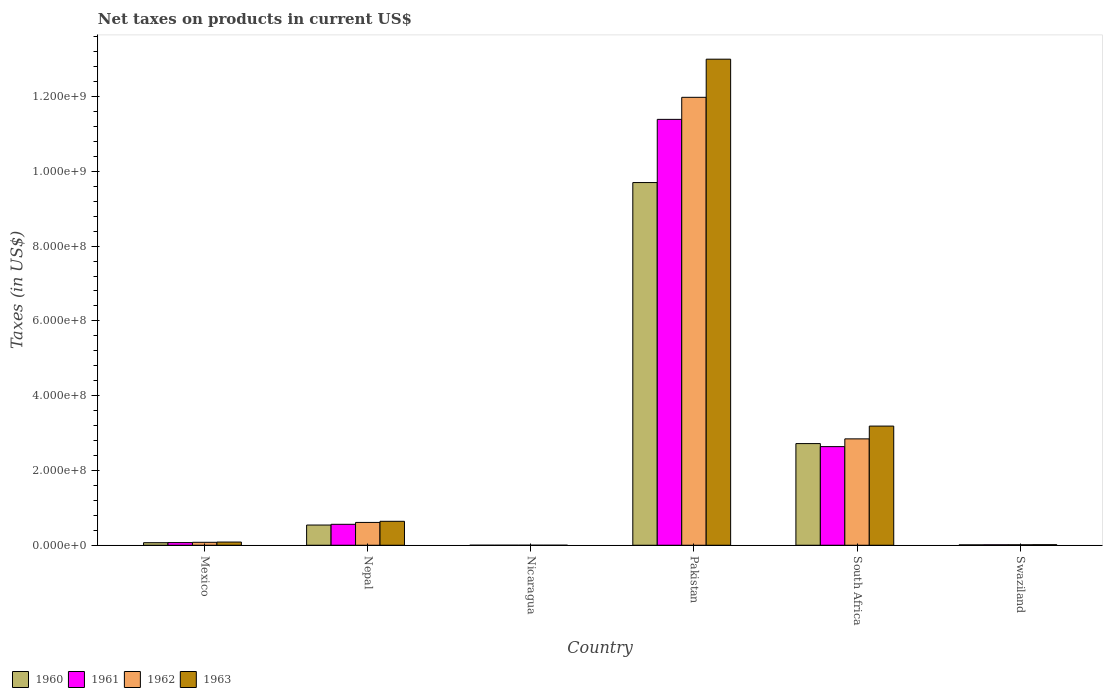How many different coloured bars are there?
Your response must be concise. 4. How many groups of bars are there?
Keep it short and to the point. 6. Are the number of bars per tick equal to the number of legend labels?
Keep it short and to the point. Yes. Are the number of bars on each tick of the X-axis equal?
Your answer should be very brief. Yes. How many bars are there on the 5th tick from the right?
Provide a succinct answer. 4. What is the label of the 2nd group of bars from the left?
Give a very brief answer. Nepal. In how many cases, is the number of bars for a given country not equal to the number of legend labels?
Offer a very short reply. 0. What is the net taxes on products in 1961 in Pakistan?
Your response must be concise. 1.14e+09. Across all countries, what is the maximum net taxes on products in 1960?
Make the answer very short. 9.70e+08. Across all countries, what is the minimum net taxes on products in 1960?
Ensure brevity in your answer.  0.03. In which country was the net taxes on products in 1961 maximum?
Your answer should be compact. Pakistan. In which country was the net taxes on products in 1963 minimum?
Provide a short and direct response. Nicaragua. What is the total net taxes on products in 1960 in the graph?
Offer a terse response. 1.30e+09. What is the difference between the net taxes on products in 1963 in Nicaragua and that in Pakistan?
Ensure brevity in your answer.  -1.30e+09. What is the difference between the net taxes on products in 1961 in South Africa and the net taxes on products in 1963 in Pakistan?
Your answer should be very brief. -1.04e+09. What is the average net taxes on products in 1960 per country?
Your answer should be very brief. 2.17e+08. What is the difference between the net taxes on products of/in 1960 and net taxes on products of/in 1962 in Nepal?
Provide a succinct answer. -7.00e+06. What is the ratio of the net taxes on products in 1961 in Nicaragua to that in South Africa?
Provide a succinct answer. 1.1808845174845643e-10. Is the net taxes on products in 1963 in Mexico less than that in Nepal?
Provide a short and direct response. Yes. What is the difference between the highest and the second highest net taxes on products in 1963?
Your answer should be compact. 2.55e+08. What is the difference between the highest and the lowest net taxes on products in 1961?
Ensure brevity in your answer.  1.14e+09. Is the sum of the net taxes on products in 1960 in Mexico and Nepal greater than the maximum net taxes on products in 1963 across all countries?
Provide a short and direct response. No. What does the 2nd bar from the left in South Africa represents?
Your answer should be very brief. 1961. What does the 3rd bar from the right in Pakistan represents?
Ensure brevity in your answer.  1961. Is it the case that in every country, the sum of the net taxes on products in 1963 and net taxes on products in 1961 is greater than the net taxes on products in 1962?
Your answer should be compact. Yes. Are all the bars in the graph horizontal?
Give a very brief answer. No. How many countries are there in the graph?
Your response must be concise. 6. Does the graph contain any zero values?
Your answer should be compact. No. Does the graph contain grids?
Give a very brief answer. No. Where does the legend appear in the graph?
Provide a succinct answer. Bottom left. How many legend labels are there?
Provide a succinct answer. 4. What is the title of the graph?
Keep it short and to the point. Net taxes on products in current US$. Does "1973" appear as one of the legend labels in the graph?
Offer a terse response. No. What is the label or title of the X-axis?
Provide a short and direct response. Country. What is the label or title of the Y-axis?
Your answer should be very brief. Taxes (in US$). What is the Taxes (in US$) in 1960 in Mexico?
Make the answer very short. 6.81e+06. What is the Taxes (in US$) in 1961 in Mexico?
Ensure brevity in your answer.  7.08e+06. What is the Taxes (in US$) in 1962 in Mexico?
Give a very brief answer. 7.85e+06. What is the Taxes (in US$) of 1963 in Mexico?
Your answer should be very brief. 8.49e+06. What is the Taxes (in US$) of 1960 in Nepal?
Provide a succinct answer. 5.40e+07. What is the Taxes (in US$) in 1961 in Nepal?
Your response must be concise. 5.60e+07. What is the Taxes (in US$) of 1962 in Nepal?
Provide a short and direct response. 6.10e+07. What is the Taxes (in US$) in 1963 in Nepal?
Provide a succinct answer. 6.40e+07. What is the Taxes (in US$) of 1960 in Nicaragua?
Your response must be concise. 0.03. What is the Taxes (in US$) of 1961 in Nicaragua?
Your response must be concise. 0.03. What is the Taxes (in US$) in 1962 in Nicaragua?
Keep it short and to the point. 0.04. What is the Taxes (in US$) in 1963 in Nicaragua?
Your answer should be compact. 0.04. What is the Taxes (in US$) of 1960 in Pakistan?
Keep it short and to the point. 9.70e+08. What is the Taxes (in US$) in 1961 in Pakistan?
Make the answer very short. 1.14e+09. What is the Taxes (in US$) of 1962 in Pakistan?
Make the answer very short. 1.20e+09. What is the Taxes (in US$) of 1963 in Pakistan?
Offer a very short reply. 1.30e+09. What is the Taxes (in US$) of 1960 in South Africa?
Give a very brief answer. 2.72e+08. What is the Taxes (in US$) in 1961 in South Africa?
Provide a succinct answer. 2.64e+08. What is the Taxes (in US$) of 1962 in South Africa?
Your answer should be very brief. 2.84e+08. What is the Taxes (in US$) in 1963 in South Africa?
Provide a succinct answer. 3.19e+08. What is the Taxes (in US$) of 1960 in Swaziland?
Give a very brief answer. 1.00e+06. What is the Taxes (in US$) in 1961 in Swaziland?
Offer a terse response. 1.21e+06. What is the Taxes (in US$) of 1962 in Swaziland?
Provide a short and direct response. 1.24e+06. What is the Taxes (in US$) in 1963 in Swaziland?
Ensure brevity in your answer.  1.47e+06. Across all countries, what is the maximum Taxes (in US$) of 1960?
Offer a terse response. 9.70e+08. Across all countries, what is the maximum Taxes (in US$) in 1961?
Give a very brief answer. 1.14e+09. Across all countries, what is the maximum Taxes (in US$) in 1962?
Provide a succinct answer. 1.20e+09. Across all countries, what is the maximum Taxes (in US$) of 1963?
Give a very brief answer. 1.30e+09. Across all countries, what is the minimum Taxes (in US$) of 1960?
Provide a short and direct response. 0.03. Across all countries, what is the minimum Taxes (in US$) in 1961?
Give a very brief answer. 0.03. Across all countries, what is the minimum Taxes (in US$) of 1962?
Offer a terse response. 0.04. Across all countries, what is the minimum Taxes (in US$) of 1963?
Offer a terse response. 0.04. What is the total Taxes (in US$) in 1960 in the graph?
Make the answer very short. 1.30e+09. What is the total Taxes (in US$) of 1961 in the graph?
Ensure brevity in your answer.  1.47e+09. What is the total Taxes (in US$) of 1962 in the graph?
Give a very brief answer. 1.55e+09. What is the total Taxes (in US$) in 1963 in the graph?
Your response must be concise. 1.69e+09. What is the difference between the Taxes (in US$) of 1960 in Mexico and that in Nepal?
Your answer should be very brief. -4.72e+07. What is the difference between the Taxes (in US$) in 1961 in Mexico and that in Nepal?
Your answer should be very brief. -4.89e+07. What is the difference between the Taxes (in US$) in 1962 in Mexico and that in Nepal?
Ensure brevity in your answer.  -5.32e+07. What is the difference between the Taxes (in US$) of 1963 in Mexico and that in Nepal?
Provide a succinct answer. -5.55e+07. What is the difference between the Taxes (in US$) in 1960 in Mexico and that in Nicaragua?
Your response must be concise. 6.81e+06. What is the difference between the Taxes (in US$) in 1961 in Mexico and that in Nicaragua?
Keep it short and to the point. 7.08e+06. What is the difference between the Taxes (in US$) of 1962 in Mexico and that in Nicaragua?
Your answer should be very brief. 7.85e+06. What is the difference between the Taxes (in US$) of 1963 in Mexico and that in Nicaragua?
Your answer should be compact. 8.49e+06. What is the difference between the Taxes (in US$) of 1960 in Mexico and that in Pakistan?
Make the answer very short. -9.63e+08. What is the difference between the Taxes (in US$) of 1961 in Mexico and that in Pakistan?
Your response must be concise. -1.13e+09. What is the difference between the Taxes (in US$) in 1962 in Mexico and that in Pakistan?
Offer a very short reply. -1.19e+09. What is the difference between the Taxes (in US$) of 1963 in Mexico and that in Pakistan?
Ensure brevity in your answer.  -1.29e+09. What is the difference between the Taxes (in US$) in 1960 in Mexico and that in South Africa?
Your answer should be very brief. -2.65e+08. What is the difference between the Taxes (in US$) of 1961 in Mexico and that in South Africa?
Your answer should be compact. -2.57e+08. What is the difference between the Taxes (in US$) in 1962 in Mexico and that in South Africa?
Offer a terse response. -2.77e+08. What is the difference between the Taxes (in US$) of 1963 in Mexico and that in South Africa?
Provide a short and direct response. -3.10e+08. What is the difference between the Taxes (in US$) of 1960 in Mexico and that in Swaziland?
Keep it short and to the point. 5.80e+06. What is the difference between the Taxes (in US$) of 1961 in Mexico and that in Swaziland?
Your answer should be very brief. 5.87e+06. What is the difference between the Taxes (in US$) in 1962 in Mexico and that in Swaziland?
Make the answer very short. 6.61e+06. What is the difference between the Taxes (in US$) in 1963 in Mexico and that in Swaziland?
Your answer should be compact. 7.02e+06. What is the difference between the Taxes (in US$) in 1960 in Nepal and that in Nicaragua?
Your answer should be compact. 5.40e+07. What is the difference between the Taxes (in US$) of 1961 in Nepal and that in Nicaragua?
Ensure brevity in your answer.  5.60e+07. What is the difference between the Taxes (in US$) of 1962 in Nepal and that in Nicaragua?
Your answer should be compact. 6.10e+07. What is the difference between the Taxes (in US$) of 1963 in Nepal and that in Nicaragua?
Give a very brief answer. 6.40e+07. What is the difference between the Taxes (in US$) in 1960 in Nepal and that in Pakistan?
Your response must be concise. -9.16e+08. What is the difference between the Taxes (in US$) of 1961 in Nepal and that in Pakistan?
Offer a terse response. -1.08e+09. What is the difference between the Taxes (in US$) of 1962 in Nepal and that in Pakistan?
Give a very brief answer. -1.14e+09. What is the difference between the Taxes (in US$) in 1963 in Nepal and that in Pakistan?
Keep it short and to the point. -1.24e+09. What is the difference between the Taxes (in US$) in 1960 in Nepal and that in South Africa?
Offer a terse response. -2.18e+08. What is the difference between the Taxes (in US$) of 1961 in Nepal and that in South Africa?
Give a very brief answer. -2.08e+08. What is the difference between the Taxes (in US$) in 1962 in Nepal and that in South Africa?
Your answer should be very brief. -2.23e+08. What is the difference between the Taxes (in US$) of 1963 in Nepal and that in South Africa?
Provide a short and direct response. -2.55e+08. What is the difference between the Taxes (in US$) of 1960 in Nepal and that in Swaziland?
Offer a very short reply. 5.30e+07. What is the difference between the Taxes (in US$) of 1961 in Nepal and that in Swaziland?
Offer a very short reply. 5.48e+07. What is the difference between the Taxes (in US$) of 1962 in Nepal and that in Swaziland?
Your answer should be compact. 5.98e+07. What is the difference between the Taxes (in US$) in 1963 in Nepal and that in Swaziland?
Make the answer very short. 6.25e+07. What is the difference between the Taxes (in US$) of 1960 in Nicaragua and that in Pakistan?
Offer a very short reply. -9.70e+08. What is the difference between the Taxes (in US$) of 1961 in Nicaragua and that in Pakistan?
Ensure brevity in your answer.  -1.14e+09. What is the difference between the Taxes (in US$) in 1962 in Nicaragua and that in Pakistan?
Provide a succinct answer. -1.20e+09. What is the difference between the Taxes (in US$) of 1963 in Nicaragua and that in Pakistan?
Offer a terse response. -1.30e+09. What is the difference between the Taxes (in US$) of 1960 in Nicaragua and that in South Africa?
Offer a very short reply. -2.72e+08. What is the difference between the Taxes (in US$) of 1961 in Nicaragua and that in South Africa?
Your answer should be very brief. -2.64e+08. What is the difference between the Taxes (in US$) of 1962 in Nicaragua and that in South Africa?
Make the answer very short. -2.84e+08. What is the difference between the Taxes (in US$) of 1963 in Nicaragua and that in South Africa?
Your response must be concise. -3.19e+08. What is the difference between the Taxes (in US$) in 1960 in Nicaragua and that in Swaziland?
Keep it short and to the point. -1.00e+06. What is the difference between the Taxes (in US$) of 1961 in Nicaragua and that in Swaziland?
Make the answer very short. -1.21e+06. What is the difference between the Taxes (in US$) of 1962 in Nicaragua and that in Swaziland?
Make the answer very short. -1.24e+06. What is the difference between the Taxes (in US$) of 1963 in Nicaragua and that in Swaziland?
Offer a terse response. -1.47e+06. What is the difference between the Taxes (in US$) in 1960 in Pakistan and that in South Africa?
Make the answer very short. 6.98e+08. What is the difference between the Taxes (in US$) of 1961 in Pakistan and that in South Africa?
Ensure brevity in your answer.  8.75e+08. What is the difference between the Taxes (in US$) in 1962 in Pakistan and that in South Africa?
Offer a very short reply. 9.14e+08. What is the difference between the Taxes (in US$) in 1963 in Pakistan and that in South Africa?
Make the answer very short. 9.81e+08. What is the difference between the Taxes (in US$) of 1960 in Pakistan and that in Swaziland?
Make the answer very short. 9.69e+08. What is the difference between the Taxes (in US$) in 1961 in Pakistan and that in Swaziland?
Keep it short and to the point. 1.14e+09. What is the difference between the Taxes (in US$) in 1962 in Pakistan and that in Swaziland?
Give a very brief answer. 1.20e+09. What is the difference between the Taxes (in US$) of 1963 in Pakistan and that in Swaziland?
Your response must be concise. 1.30e+09. What is the difference between the Taxes (in US$) in 1960 in South Africa and that in Swaziland?
Make the answer very short. 2.71e+08. What is the difference between the Taxes (in US$) of 1961 in South Africa and that in Swaziland?
Keep it short and to the point. 2.63e+08. What is the difference between the Taxes (in US$) of 1962 in South Africa and that in Swaziland?
Give a very brief answer. 2.83e+08. What is the difference between the Taxes (in US$) of 1963 in South Africa and that in Swaziland?
Offer a terse response. 3.17e+08. What is the difference between the Taxes (in US$) in 1960 in Mexico and the Taxes (in US$) in 1961 in Nepal?
Keep it short and to the point. -4.92e+07. What is the difference between the Taxes (in US$) of 1960 in Mexico and the Taxes (in US$) of 1962 in Nepal?
Provide a succinct answer. -5.42e+07. What is the difference between the Taxes (in US$) in 1960 in Mexico and the Taxes (in US$) in 1963 in Nepal?
Offer a terse response. -5.72e+07. What is the difference between the Taxes (in US$) in 1961 in Mexico and the Taxes (in US$) in 1962 in Nepal?
Provide a succinct answer. -5.39e+07. What is the difference between the Taxes (in US$) in 1961 in Mexico and the Taxes (in US$) in 1963 in Nepal?
Offer a very short reply. -5.69e+07. What is the difference between the Taxes (in US$) in 1962 in Mexico and the Taxes (in US$) in 1963 in Nepal?
Your answer should be compact. -5.62e+07. What is the difference between the Taxes (in US$) in 1960 in Mexico and the Taxes (in US$) in 1961 in Nicaragua?
Keep it short and to the point. 6.81e+06. What is the difference between the Taxes (in US$) in 1960 in Mexico and the Taxes (in US$) in 1962 in Nicaragua?
Give a very brief answer. 6.81e+06. What is the difference between the Taxes (in US$) in 1960 in Mexico and the Taxes (in US$) in 1963 in Nicaragua?
Provide a short and direct response. 6.81e+06. What is the difference between the Taxes (in US$) in 1961 in Mexico and the Taxes (in US$) in 1962 in Nicaragua?
Your answer should be very brief. 7.08e+06. What is the difference between the Taxes (in US$) in 1961 in Mexico and the Taxes (in US$) in 1963 in Nicaragua?
Ensure brevity in your answer.  7.08e+06. What is the difference between the Taxes (in US$) of 1962 in Mexico and the Taxes (in US$) of 1963 in Nicaragua?
Provide a short and direct response. 7.85e+06. What is the difference between the Taxes (in US$) of 1960 in Mexico and the Taxes (in US$) of 1961 in Pakistan?
Your response must be concise. -1.13e+09. What is the difference between the Taxes (in US$) in 1960 in Mexico and the Taxes (in US$) in 1962 in Pakistan?
Give a very brief answer. -1.19e+09. What is the difference between the Taxes (in US$) in 1960 in Mexico and the Taxes (in US$) in 1963 in Pakistan?
Give a very brief answer. -1.29e+09. What is the difference between the Taxes (in US$) of 1961 in Mexico and the Taxes (in US$) of 1962 in Pakistan?
Make the answer very short. -1.19e+09. What is the difference between the Taxes (in US$) in 1961 in Mexico and the Taxes (in US$) in 1963 in Pakistan?
Your answer should be very brief. -1.29e+09. What is the difference between the Taxes (in US$) of 1962 in Mexico and the Taxes (in US$) of 1963 in Pakistan?
Offer a very short reply. -1.29e+09. What is the difference between the Taxes (in US$) of 1960 in Mexico and the Taxes (in US$) of 1961 in South Africa?
Make the answer very short. -2.57e+08. What is the difference between the Taxes (in US$) in 1960 in Mexico and the Taxes (in US$) in 1962 in South Africa?
Offer a terse response. -2.78e+08. What is the difference between the Taxes (in US$) of 1960 in Mexico and the Taxes (in US$) of 1963 in South Africa?
Your answer should be compact. -3.12e+08. What is the difference between the Taxes (in US$) in 1961 in Mexico and the Taxes (in US$) in 1962 in South Africa?
Your answer should be compact. -2.77e+08. What is the difference between the Taxes (in US$) in 1961 in Mexico and the Taxes (in US$) in 1963 in South Africa?
Your answer should be compact. -3.12e+08. What is the difference between the Taxes (in US$) in 1962 in Mexico and the Taxes (in US$) in 1963 in South Africa?
Your answer should be very brief. -3.11e+08. What is the difference between the Taxes (in US$) in 1960 in Mexico and the Taxes (in US$) in 1961 in Swaziland?
Your answer should be compact. 5.60e+06. What is the difference between the Taxes (in US$) in 1960 in Mexico and the Taxes (in US$) in 1962 in Swaziland?
Offer a terse response. 5.57e+06. What is the difference between the Taxes (in US$) of 1960 in Mexico and the Taxes (in US$) of 1963 in Swaziland?
Provide a succinct answer. 5.33e+06. What is the difference between the Taxes (in US$) in 1961 in Mexico and the Taxes (in US$) in 1962 in Swaziland?
Your answer should be very brief. 5.84e+06. What is the difference between the Taxes (in US$) of 1961 in Mexico and the Taxes (in US$) of 1963 in Swaziland?
Make the answer very short. 5.61e+06. What is the difference between the Taxes (in US$) of 1962 in Mexico and the Taxes (in US$) of 1963 in Swaziland?
Your answer should be compact. 6.37e+06. What is the difference between the Taxes (in US$) of 1960 in Nepal and the Taxes (in US$) of 1961 in Nicaragua?
Your answer should be compact. 5.40e+07. What is the difference between the Taxes (in US$) in 1960 in Nepal and the Taxes (in US$) in 1962 in Nicaragua?
Your answer should be very brief. 5.40e+07. What is the difference between the Taxes (in US$) of 1960 in Nepal and the Taxes (in US$) of 1963 in Nicaragua?
Make the answer very short. 5.40e+07. What is the difference between the Taxes (in US$) of 1961 in Nepal and the Taxes (in US$) of 1962 in Nicaragua?
Your answer should be compact. 5.60e+07. What is the difference between the Taxes (in US$) of 1961 in Nepal and the Taxes (in US$) of 1963 in Nicaragua?
Make the answer very short. 5.60e+07. What is the difference between the Taxes (in US$) of 1962 in Nepal and the Taxes (in US$) of 1963 in Nicaragua?
Offer a very short reply. 6.10e+07. What is the difference between the Taxes (in US$) of 1960 in Nepal and the Taxes (in US$) of 1961 in Pakistan?
Your answer should be compact. -1.08e+09. What is the difference between the Taxes (in US$) in 1960 in Nepal and the Taxes (in US$) in 1962 in Pakistan?
Your answer should be very brief. -1.14e+09. What is the difference between the Taxes (in US$) in 1960 in Nepal and the Taxes (in US$) in 1963 in Pakistan?
Make the answer very short. -1.25e+09. What is the difference between the Taxes (in US$) in 1961 in Nepal and the Taxes (in US$) in 1962 in Pakistan?
Offer a very short reply. -1.14e+09. What is the difference between the Taxes (in US$) in 1961 in Nepal and the Taxes (in US$) in 1963 in Pakistan?
Give a very brief answer. -1.24e+09. What is the difference between the Taxes (in US$) of 1962 in Nepal and the Taxes (in US$) of 1963 in Pakistan?
Give a very brief answer. -1.24e+09. What is the difference between the Taxes (in US$) in 1960 in Nepal and the Taxes (in US$) in 1961 in South Africa?
Provide a succinct answer. -2.10e+08. What is the difference between the Taxes (in US$) in 1960 in Nepal and the Taxes (in US$) in 1962 in South Africa?
Ensure brevity in your answer.  -2.30e+08. What is the difference between the Taxes (in US$) of 1960 in Nepal and the Taxes (in US$) of 1963 in South Africa?
Your answer should be compact. -2.65e+08. What is the difference between the Taxes (in US$) of 1961 in Nepal and the Taxes (in US$) of 1962 in South Africa?
Provide a succinct answer. -2.28e+08. What is the difference between the Taxes (in US$) in 1961 in Nepal and the Taxes (in US$) in 1963 in South Africa?
Provide a succinct answer. -2.63e+08. What is the difference between the Taxes (in US$) in 1962 in Nepal and the Taxes (in US$) in 1963 in South Africa?
Your response must be concise. -2.58e+08. What is the difference between the Taxes (in US$) in 1960 in Nepal and the Taxes (in US$) in 1961 in Swaziland?
Ensure brevity in your answer.  5.28e+07. What is the difference between the Taxes (in US$) in 1960 in Nepal and the Taxes (in US$) in 1962 in Swaziland?
Give a very brief answer. 5.28e+07. What is the difference between the Taxes (in US$) of 1960 in Nepal and the Taxes (in US$) of 1963 in Swaziland?
Your answer should be compact. 5.25e+07. What is the difference between the Taxes (in US$) of 1961 in Nepal and the Taxes (in US$) of 1962 in Swaziland?
Make the answer very short. 5.48e+07. What is the difference between the Taxes (in US$) of 1961 in Nepal and the Taxes (in US$) of 1963 in Swaziland?
Offer a very short reply. 5.45e+07. What is the difference between the Taxes (in US$) of 1962 in Nepal and the Taxes (in US$) of 1963 in Swaziland?
Provide a short and direct response. 5.95e+07. What is the difference between the Taxes (in US$) of 1960 in Nicaragua and the Taxes (in US$) of 1961 in Pakistan?
Provide a succinct answer. -1.14e+09. What is the difference between the Taxes (in US$) of 1960 in Nicaragua and the Taxes (in US$) of 1962 in Pakistan?
Your answer should be very brief. -1.20e+09. What is the difference between the Taxes (in US$) in 1960 in Nicaragua and the Taxes (in US$) in 1963 in Pakistan?
Offer a terse response. -1.30e+09. What is the difference between the Taxes (in US$) of 1961 in Nicaragua and the Taxes (in US$) of 1962 in Pakistan?
Your response must be concise. -1.20e+09. What is the difference between the Taxes (in US$) of 1961 in Nicaragua and the Taxes (in US$) of 1963 in Pakistan?
Provide a succinct answer. -1.30e+09. What is the difference between the Taxes (in US$) in 1962 in Nicaragua and the Taxes (in US$) in 1963 in Pakistan?
Your response must be concise. -1.30e+09. What is the difference between the Taxes (in US$) in 1960 in Nicaragua and the Taxes (in US$) in 1961 in South Africa?
Offer a very short reply. -2.64e+08. What is the difference between the Taxes (in US$) in 1960 in Nicaragua and the Taxes (in US$) in 1962 in South Africa?
Give a very brief answer. -2.84e+08. What is the difference between the Taxes (in US$) of 1960 in Nicaragua and the Taxes (in US$) of 1963 in South Africa?
Your answer should be very brief. -3.19e+08. What is the difference between the Taxes (in US$) in 1961 in Nicaragua and the Taxes (in US$) in 1962 in South Africa?
Ensure brevity in your answer.  -2.84e+08. What is the difference between the Taxes (in US$) in 1961 in Nicaragua and the Taxes (in US$) in 1963 in South Africa?
Keep it short and to the point. -3.19e+08. What is the difference between the Taxes (in US$) in 1962 in Nicaragua and the Taxes (in US$) in 1963 in South Africa?
Ensure brevity in your answer.  -3.19e+08. What is the difference between the Taxes (in US$) in 1960 in Nicaragua and the Taxes (in US$) in 1961 in Swaziland?
Give a very brief answer. -1.21e+06. What is the difference between the Taxes (in US$) of 1960 in Nicaragua and the Taxes (in US$) of 1962 in Swaziland?
Offer a terse response. -1.24e+06. What is the difference between the Taxes (in US$) in 1960 in Nicaragua and the Taxes (in US$) in 1963 in Swaziland?
Offer a very short reply. -1.47e+06. What is the difference between the Taxes (in US$) of 1961 in Nicaragua and the Taxes (in US$) of 1962 in Swaziland?
Make the answer very short. -1.24e+06. What is the difference between the Taxes (in US$) of 1961 in Nicaragua and the Taxes (in US$) of 1963 in Swaziland?
Keep it short and to the point. -1.47e+06. What is the difference between the Taxes (in US$) of 1962 in Nicaragua and the Taxes (in US$) of 1963 in Swaziland?
Your answer should be compact. -1.47e+06. What is the difference between the Taxes (in US$) in 1960 in Pakistan and the Taxes (in US$) in 1961 in South Africa?
Ensure brevity in your answer.  7.06e+08. What is the difference between the Taxes (in US$) of 1960 in Pakistan and the Taxes (in US$) of 1962 in South Africa?
Provide a short and direct response. 6.86e+08. What is the difference between the Taxes (in US$) in 1960 in Pakistan and the Taxes (in US$) in 1963 in South Africa?
Give a very brief answer. 6.51e+08. What is the difference between the Taxes (in US$) in 1961 in Pakistan and the Taxes (in US$) in 1962 in South Africa?
Provide a succinct answer. 8.55e+08. What is the difference between the Taxes (in US$) in 1961 in Pakistan and the Taxes (in US$) in 1963 in South Africa?
Make the answer very short. 8.20e+08. What is the difference between the Taxes (in US$) in 1962 in Pakistan and the Taxes (in US$) in 1963 in South Africa?
Offer a terse response. 8.79e+08. What is the difference between the Taxes (in US$) of 1960 in Pakistan and the Taxes (in US$) of 1961 in Swaziland?
Offer a terse response. 9.69e+08. What is the difference between the Taxes (in US$) of 1960 in Pakistan and the Taxes (in US$) of 1962 in Swaziland?
Your answer should be very brief. 9.69e+08. What is the difference between the Taxes (in US$) of 1960 in Pakistan and the Taxes (in US$) of 1963 in Swaziland?
Your response must be concise. 9.69e+08. What is the difference between the Taxes (in US$) in 1961 in Pakistan and the Taxes (in US$) in 1962 in Swaziland?
Ensure brevity in your answer.  1.14e+09. What is the difference between the Taxes (in US$) of 1961 in Pakistan and the Taxes (in US$) of 1963 in Swaziland?
Your response must be concise. 1.14e+09. What is the difference between the Taxes (in US$) of 1962 in Pakistan and the Taxes (in US$) of 1963 in Swaziland?
Your answer should be very brief. 1.20e+09. What is the difference between the Taxes (in US$) in 1960 in South Africa and the Taxes (in US$) in 1961 in Swaziland?
Give a very brief answer. 2.71e+08. What is the difference between the Taxes (in US$) of 1960 in South Africa and the Taxes (in US$) of 1962 in Swaziland?
Provide a short and direct response. 2.71e+08. What is the difference between the Taxes (in US$) in 1960 in South Africa and the Taxes (in US$) in 1963 in Swaziland?
Give a very brief answer. 2.70e+08. What is the difference between the Taxes (in US$) of 1961 in South Africa and the Taxes (in US$) of 1962 in Swaziland?
Offer a very short reply. 2.63e+08. What is the difference between the Taxes (in US$) of 1961 in South Africa and the Taxes (in US$) of 1963 in Swaziland?
Your answer should be compact. 2.62e+08. What is the difference between the Taxes (in US$) of 1962 in South Africa and the Taxes (in US$) of 1963 in Swaziland?
Offer a terse response. 2.83e+08. What is the average Taxes (in US$) in 1960 per country?
Keep it short and to the point. 2.17e+08. What is the average Taxes (in US$) of 1961 per country?
Offer a very short reply. 2.45e+08. What is the average Taxes (in US$) in 1962 per country?
Ensure brevity in your answer.  2.59e+08. What is the average Taxes (in US$) in 1963 per country?
Provide a succinct answer. 2.82e+08. What is the difference between the Taxes (in US$) in 1960 and Taxes (in US$) in 1961 in Mexico?
Your answer should be compact. -2.73e+05. What is the difference between the Taxes (in US$) of 1960 and Taxes (in US$) of 1962 in Mexico?
Provide a short and direct response. -1.04e+06. What is the difference between the Taxes (in US$) in 1960 and Taxes (in US$) in 1963 in Mexico?
Offer a very short reply. -1.69e+06. What is the difference between the Taxes (in US$) of 1961 and Taxes (in US$) of 1962 in Mexico?
Keep it short and to the point. -7.69e+05. What is the difference between the Taxes (in US$) of 1961 and Taxes (in US$) of 1963 in Mexico?
Offer a terse response. -1.41e+06. What is the difference between the Taxes (in US$) in 1962 and Taxes (in US$) in 1963 in Mexico?
Give a very brief answer. -6.43e+05. What is the difference between the Taxes (in US$) of 1960 and Taxes (in US$) of 1961 in Nepal?
Your response must be concise. -2.00e+06. What is the difference between the Taxes (in US$) of 1960 and Taxes (in US$) of 1962 in Nepal?
Keep it short and to the point. -7.00e+06. What is the difference between the Taxes (in US$) of 1960 and Taxes (in US$) of 1963 in Nepal?
Offer a terse response. -1.00e+07. What is the difference between the Taxes (in US$) of 1961 and Taxes (in US$) of 1962 in Nepal?
Make the answer very short. -5.00e+06. What is the difference between the Taxes (in US$) in 1961 and Taxes (in US$) in 1963 in Nepal?
Ensure brevity in your answer.  -8.00e+06. What is the difference between the Taxes (in US$) of 1962 and Taxes (in US$) of 1963 in Nepal?
Ensure brevity in your answer.  -3.00e+06. What is the difference between the Taxes (in US$) of 1960 and Taxes (in US$) of 1961 in Nicaragua?
Your answer should be compact. -0. What is the difference between the Taxes (in US$) of 1960 and Taxes (in US$) of 1962 in Nicaragua?
Make the answer very short. -0.01. What is the difference between the Taxes (in US$) of 1960 and Taxes (in US$) of 1963 in Nicaragua?
Give a very brief answer. -0.01. What is the difference between the Taxes (in US$) of 1961 and Taxes (in US$) of 1962 in Nicaragua?
Provide a succinct answer. -0. What is the difference between the Taxes (in US$) in 1961 and Taxes (in US$) in 1963 in Nicaragua?
Keep it short and to the point. -0.01. What is the difference between the Taxes (in US$) of 1962 and Taxes (in US$) of 1963 in Nicaragua?
Give a very brief answer. -0.01. What is the difference between the Taxes (in US$) in 1960 and Taxes (in US$) in 1961 in Pakistan?
Provide a succinct answer. -1.69e+08. What is the difference between the Taxes (in US$) in 1960 and Taxes (in US$) in 1962 in Pakistan?
Your response must be concise. -2.28e+08. What is the difference between the Taxes (in US$) in 1960 and Taxes (in US$) in 1963 in Pakistan?
Your answer should be very brief. -3.30e+08. What is the difference between the Taxes (in US$) of 1961 and Taxes (in US$) of 1962 in Pakistan?
Your answer should be compact. -5.90e+07. What is the difference between the Taxes (in US$) of 1961 and Taxes (in US$) of 1963 in Pakistan?
Make the answer very short. -1.61e+08. What is the difference between the Taxes (in US$) in 1962 and Taxes (in US$) in 1963 in Pakistan?
Your answer should be compact. -1.02e+08. What is the difference between the Taxes (in US$) of 1960 and Taxes (in US$) of 1961 in South Africa?
Ensure brevity in your answer.  8.10e+06. What is the difference between the Taxes (in US$) of 1960 and Taxes (in US$) of 1962 in South Africa?
Your response must be concise. -1.26e+07. What is the difference between the Taxes (in US$) of 1960 and Taxes (in US$) of 1963 in South Africa?
Provide a succinct answer. -4.68e+07. What is the difference between the Taxes (in US$) in 1961 and Taxes (in US$) in 1962 in South Africa?
Your response must be concise. -2.07e+07. What is the difference between the Taxes (in US$) in 1961 and Taxes (in US$) in 1963 in South Africa?
Offer a very short reply. -5.49e+07. What is the difference between the Taxes (in US$) in 1962 and Taxes (in US$) in 1963 in South Africa?
Make the answer very short. -3.42e+07. What is the difference between the Taxes (in US$) in 1960 and Taxes (in US$) in 1961 in Swaziland?
Offer a very short reply. -2.06e+05. What is the difference between the Taxes (in US$) in 1960 and Taxes (in US$) in 1962 in Swaziland?
Ensure brevity in your answer.  -2.36e+05. What is the difference between the Taxes (in US$) in 1960 and Taxes (in US$) in 1963 in Swaziland?
Provide a succinct answer. -4.72e+05. What is the difference between the Taxes (in US$) in 1961 and Taxes (in US$) in 1962 in Swaziland?
Make the answer very short. -2.95e+04. What is the difference between the Taxes (in US$) of 1961 and Taxes (in US$) of 1963 in Swaziland?
Make the answer very short. -2.65e+05. What is the difference between the Taxes (in US$) in 1962 and Taxes (in US$) in 1963 in Swaziland?
Your answer should be very brief. -2.36e+05. What is the ratio of the Taxes (in US$) of 1960 in Mexico to that in Nepal?
Provide a succinct answer. 0.13. What is the ratio of the Taxes (in US$) of 1961 in Mexico to that in Nepal?
Keep it short and to the point. 0.13. What is the ratio of the Taxes (in US$) in 1962 in Mexico to that in Nepal?
Make the answer very short. 0.13. What is the ratio of the Taxes (in US$) in 1963 in Mexico to that in Nepal?
Keep it short and to the point. 0.13. What is the ratio of the Taxes (in US$) in 1960 in Mexico to that in Nicaragua?
Make the answer very short. 2.29e+08. What is the ratio of the Taxes (in US$) of 1961 in Mexico to that in Nicaragua?
Offer a very short reply. 2.27e+08. What is the ratio of the Taxes (in US$) of 1962 in Mexico to that in Nicaragua?
Provide a succinct answer. 2.22e+08. What is the ratio of the Taxes (in US$) in 1963 in Mexico to that in Nicaragua?
Your answer should be compact. 2.04e+08. What is the ratio of the Taxes (in US$) in 1960 in Mexico to that in Pakistan?
Make the answer very short. 0.01. What is the ratio of the Taxes (in US$) of 1961 in Mexico to that in Pakistan?
Offer a very short reply. 0.01. What is the ratio of the Taxes (in US$) in 1962 in Mexico to that in Pakistan?
Provide a short and direct response. 0.01. What is the ratio of the Taxes (in US$) of 1963 in Mexico to that in Pakistan?
Provide a succinct answer. 0.01. What is the ratio of the Taxes (in US$) of 1960 in Mexico to that in South Africa?
Your response must be concise. 0.03. What is the ratio of the Taxes (in US$) of 1961 in Mexico to that in South Africa?
Provide a succinct answer. 0.03. What is the ratio of the Taxes (in US$) of 1962 in Mexico to that in South Africa?
Your answer should be compact. 0.03. What is the ratio of the Taxes (in US$) in 1963 in Mexico to that in South Africa?
Offer a very short reply. 0.03. What is the ratio of the Taxes (in US$) in 1960 in Mexico to that in Swaziland?
Ensure brevity in your answer.  6.79. What is the ratio of the Taxes (in US$) of 1961 in Mexico to that in Swaziland?
Your answer should be very brief. 5.86. What is the ratio of the Taxes (in US$) of 1962 in Mexico to that in Swaziland?
Provide a succinct answer. 6.34. What is the ratio of the Taxes (in US$) in 1963 in Mexico to that in Swaziland?
Keep it short and to the point. 5.76. What is the ratio of the Taxes (in US$) in 1960 in Nepal to that in Nicaragua?
Offer a terse response. 1.81e+09. What is the ratio of the Taxes (in US$) of 1961 in Nepal to that in Nicaragua?
Provide a short and direct response. 1.80e+09. What is the ratio of the Taxes (in US$) of 1962 in Nepal to that in Nicaragua?
Offer a terse response. 1.73e+09. What is the ratio of the Taxes (in US$) of 1963 in Nepal to that in Nicaragua?
Offer a terse response. 1.54e+09. What is the ratio of the Taxes (in US$) of 1960 in Nepal to that in Pakistan?
Offer a terse response. 0.06. What is the ratio of the Taxes (in US$) of 1961 in Nepal to that in Pakistan?
Keep it short and to the point. 0.05. What is the ratio of the Taxes (in US$) in 1962 in Nepal to that in Pakistan?
Ensure brevity in your answer.  0.05. What is the ratio of the Taxes (in US$) of 1963 in Nepal to that in Pakistan?
Offer a very short reply. 0.05. What is the ratio of the Taxes (in US$) in 1960 in Nepal to that in South Africa?
Your answer should be very brief. 0.2. What is the ratio of the Taxes (in US$) in 1961 in Nepal to that in South Africa?
Your answer should be very brief. 0.21. What is the ratio of the Taxes (in US$) in 1962 in Nepal to that in South Africa?
Your answer should be compact. 0.21. What is the ratio of the Taxes (in US$) of 1963 in Nepal to that in South Africa?
Offer a very short reply. 0.2. What is the ratio of the Taxes (in US$) in 1960 in Nepal to that in Swaziland?
Provide a succinct answer. 53.86. What is the ratio of the Taxes (in US$) of 1961 in Nepal to that in Swaziland?
Offer a terse response. 46.32. What is the ratio of the Taxes (in US$) in 1962 in Nepal to that in Swaziland?
Offer a very short reply. 49.25. What is the ratio of the Taxes (in US$) in 1963 in Nepal to that in Swaziland?
Provide a succinct answer. 43.41. What is the ratio of the Taxes (in US$) in 1960 in Nicaragua to that in Pakistan?
Your answer should be very brief. 0. What is the ratio of the Taxes (in US$) in 1961 in Nicaragua to that in Pakistan?
Your answer should be compact. 0. What is the ratio of the Taxes (in US$) in 1962 in Nicaragua to that in Pakistan?
Make the answer very short. 0. What is the ratio of the Taxes (in US$) of 1961 in Nicaragua to that in South Africa?
Provide a short and direct response. 0. What is the ratio of the Taxes (in US$) of 1963 in Nicaragua to that in South Africa?
Your answer should be compact. 0. What is the ratio of the Taxes (in US$) of 1961 in Nicaragua to that in Swaziland?
Offer a very short reply. 0. What is the ratio of the Taxes (in US$) in 1963 in Nicaragua to that in Swaziland?
Provide a short and direct response. 0. What is the ratio of the Taxes (in US$) of 1960 in Pakistan to that in South Africa?
Make the answer very short. 3.57. What is the ratio of the Taxes (in US$) in 1961 in Pakistan to that in South Africa?
Give a very brief answer. 4.32. What is the ratio of the Taxes (in US$) of 1962 in Pakistan to that in South Africa?
Ensure brevity in your answer.  4.21. What is the ratio of the Taxes (in US$) of 1963 in Pakistan to that in South Africa?
Keep it short and to the point. 4.08. What is the ratio of the Taxes (in US$) of 1960 in Pakistan to that in Swaziland?
Provide a short and direct response. 967.48. What is the ratio of the Taxes (in US$) of 1961 in Pakistan to that in Swaziland?
Provide a short and direct response. 942.1. What is the ratio of the Taxes (in US$) in 1962 in Pakistan to that in Swaziland?
Your answer should be very brief. 967.3. What is the ratio of the Taxes (in US$) in 1963 in Pakistan to that in Swaziland?
Your response must be concise. 881.71. What is the ratio of the Taxes (in US$) in 1960 in South Africa to that in Swaziland?
Provide a succinct answer. 271.17. What is the ratio of the Taxes (in US$) of 1961 in South Africa to that in Swaziland?
Give a very brief answer. 218.17. What is the ratio of the Taxes (in US$) of 1962 in South Africa to that in Swaziland?
Keep it short and to the point. 229.69. What is the ratio of the Taxes (in US$) of 1963 in South Africa to that in Swaziland?
Your response must be concise. 216.15. What is the difference between the highest and the second highest Taxes (in US$) in 1960?
Your answer should be very brief. 6.98e+08. What is the difference between the highest and the second highest Taxes (in US$) in 1961?
Offer a terse response. 8.75e+08. What is the difference between the highest and the second highest Taxes (in US$) in 1962?
Keep it short and to the point. 9.14e+08. What is the difference between the highest and the second highest Taxes (in US$) of 1963?
Provide a short and direct response. 9.81e+08. What is the difference between the highest and the lowest Taxes (in US$) of 1960?
Make the answer very short. 9.70e+08. What is the difference between the highest and the lowest Taxes (in US$) of 1961?
Offer a terse response. 1.14e+09. What is the difference between the highest and the lowest Taxes (in US$) of 1962?
Offer a terse response. 1.20e+09. What is the difference between the highest and the lowest Taxes (in US$) of 1963?
Provide a short and direct response. 1.30e+09. 